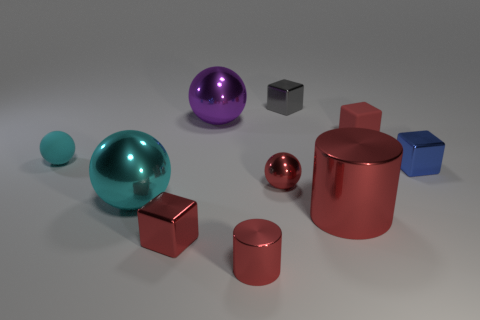Subtract 1 spheres. How many spheres are left? 3 Subtract all balls. How many objects are left? 6 Add 1 yellow metallic spheres. How many yellow metallic spheres exist? 1 Subtract 1 gray cubes. How many objects are left? 9 Subtract all tiny brown metallic cubes. Subtract all tiny red objects. How many objects are left? 6 Add 1 gray metallic objects. How many gray metallic objects are left? 2 